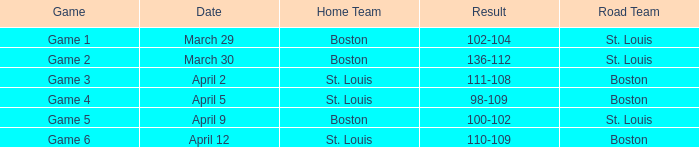For the game on april 12 where st. louis is the home team, what is its designated number? Game 6. 